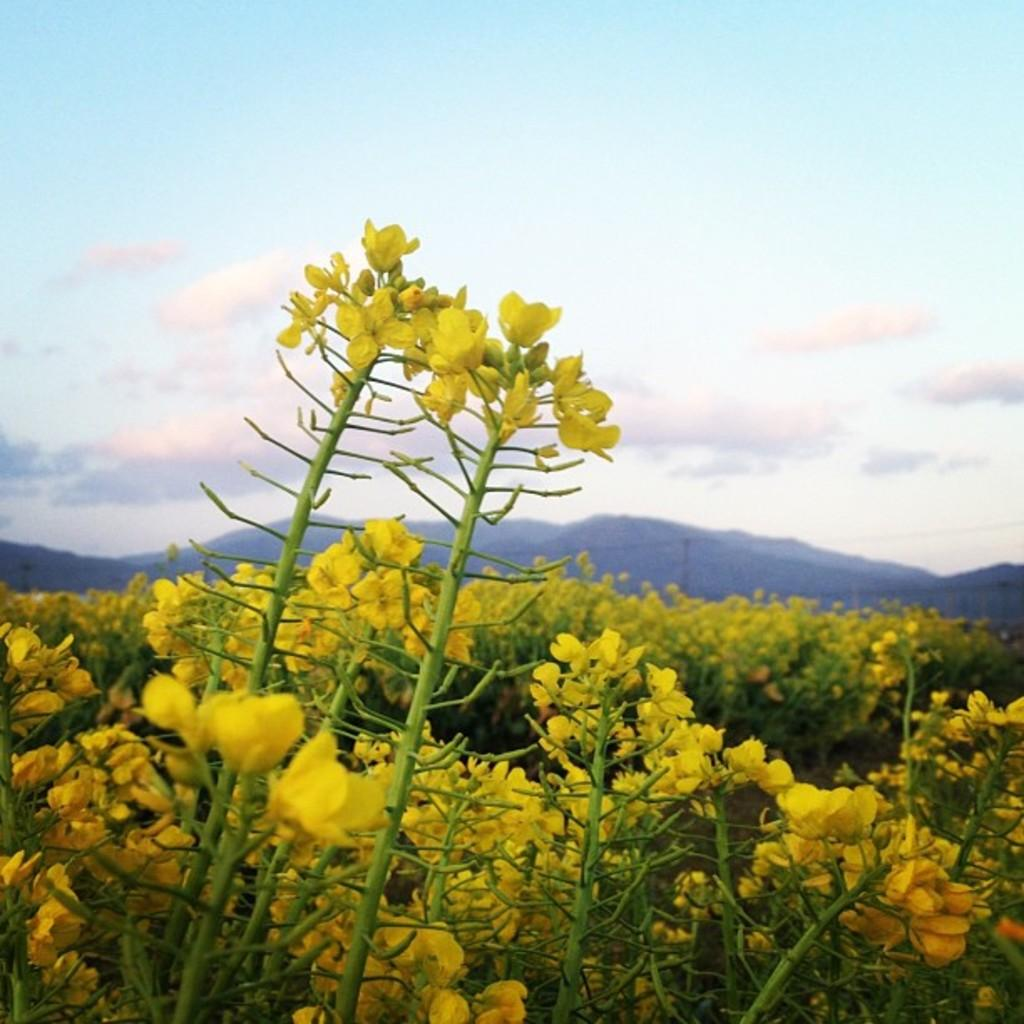What objects are on the ground in the image? There are planets on the ground in the image. What is growing on the planets? The planets have flowers on them. What can be seen in the distance in the image? There are mountains visible in the background of the image. What is visible above the mountains in the image? The sky is visible in the background of the image, and clouds are present in the sky. How many legs does the class have in the image? There is no class present in the image, and therefore no legs can be attributed to it. What type of stamp can be seen on the mountains in the image? There is no stamp present on the mountains in the image; they are natural formations. 